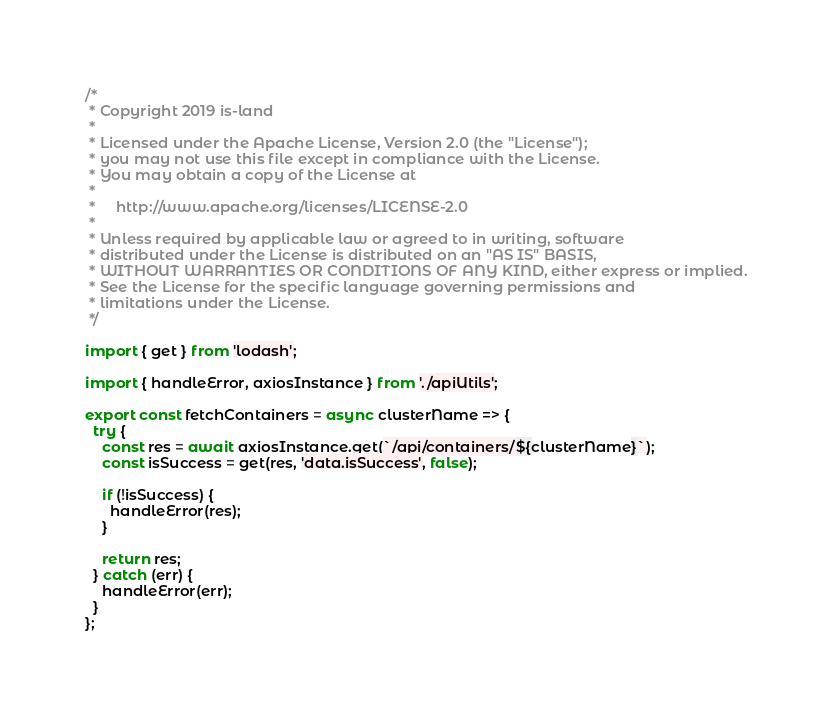Convert code to text. <code><loc_0><loc_0><loc_500><loc_500><_JavaScript_>/*
 * Copyright 2019 is-land
 *
 * Licensed under the Apache License, Version 2.0 (the "License");
 * you may not use this file except in compliance with the License.
 * You may obtain a copy of the License at
 *
 *     http://www.apache.org/licenses/LICENSE-2.0
 *
 * Unless required by applicable law or agreed to in writing, software
 * distributed under the License is distributed on an "AS IS" BASIS,
 * WITHOUT WARRANTIES OR CONDITIONS OF ANY KIND, either express or implied.
 * See the License for the specific language governing permissions and
 * limitations under the License.
 */

import { get } from 'lodash';

import { handleError, axiosInstance } from './apiUtils';

export const fetchContainers = async clusterName => {
  try {
    const res = await axiosInstance.get(`/api/containers/${clusterName}`);
    const isSuccess = get(res, 'data.isSuccess', false);

    if (!isSuccess) {
      handleError(res);
    }

    return res;
  } catch (err) {
    handleError(err);
  }
};
</code> 